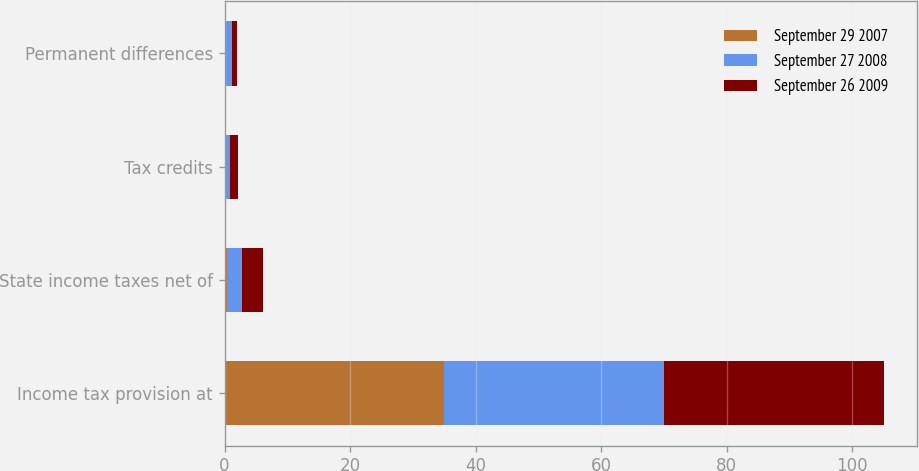Convert chart. <chart><loc_0><loc_0><loc_500><loc_500><stacked_bar_chart><ecel><fcel>Income tax provision at<fcel>State income taxes net of<fcel>Tax credits<fcel>Permanent differences<nl><fcel>September 29 2007<fcel>35<fcel>0.3<fcel>0.2<fcel>0.2<nl><fcel>September 27 2008<fcel>35<fcel>2.5<fcel>0.6<fcel>1<nl><fcel>September 26 2009<fcel>35<fcel>3.3<fcel>1.4<fcel>0.7<nl></chart> 